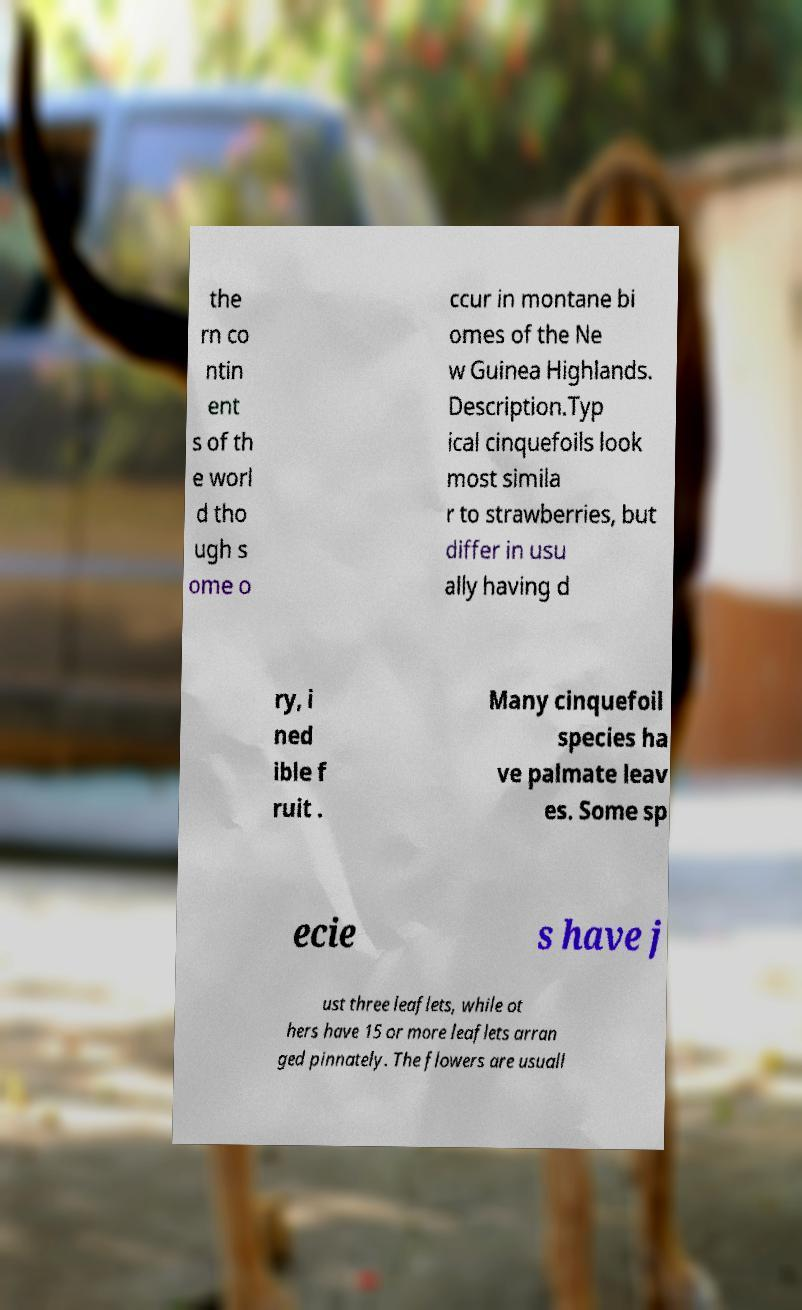There's text embedded in this image that I need extracted. Can you transcribe it verbatim? the rn co ntin ent s of th e worl d tho ugh s ome o ccur in montane bi omes of the Ne w Guinea Highlands. Description.Typ ical cinquefoils look most simila r to strawberries, but differ in usu ally having d ry, i ned ible f ruit . Many cinquefoil species ha ve palmate leav es. Some sp ecie s have j ust three leaflets, while ot hers have 15 or more leaflets arran ged pinnately. The flowers are usuall 